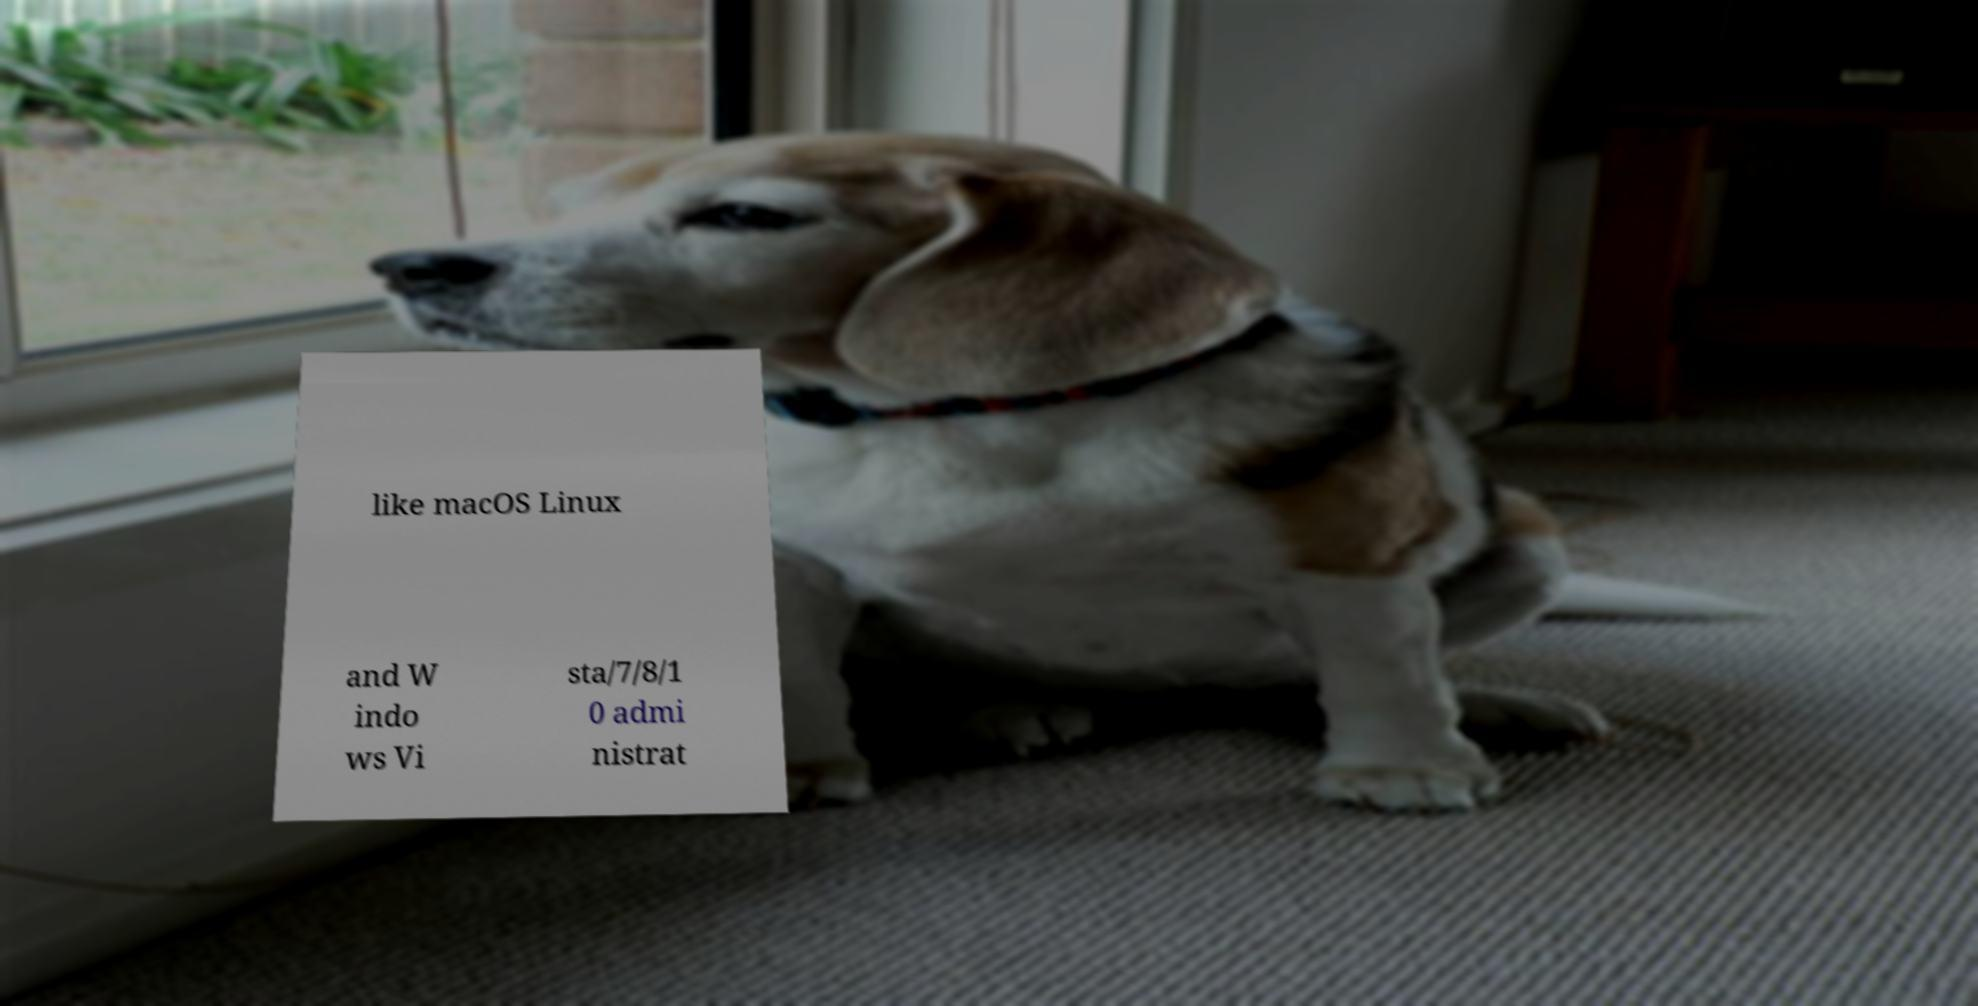What messages or text are displayed in this image? I need them in a readable, typed format. like macOS Linux and W indo ws Vi sta/7/8/1 0 admi nistrat 